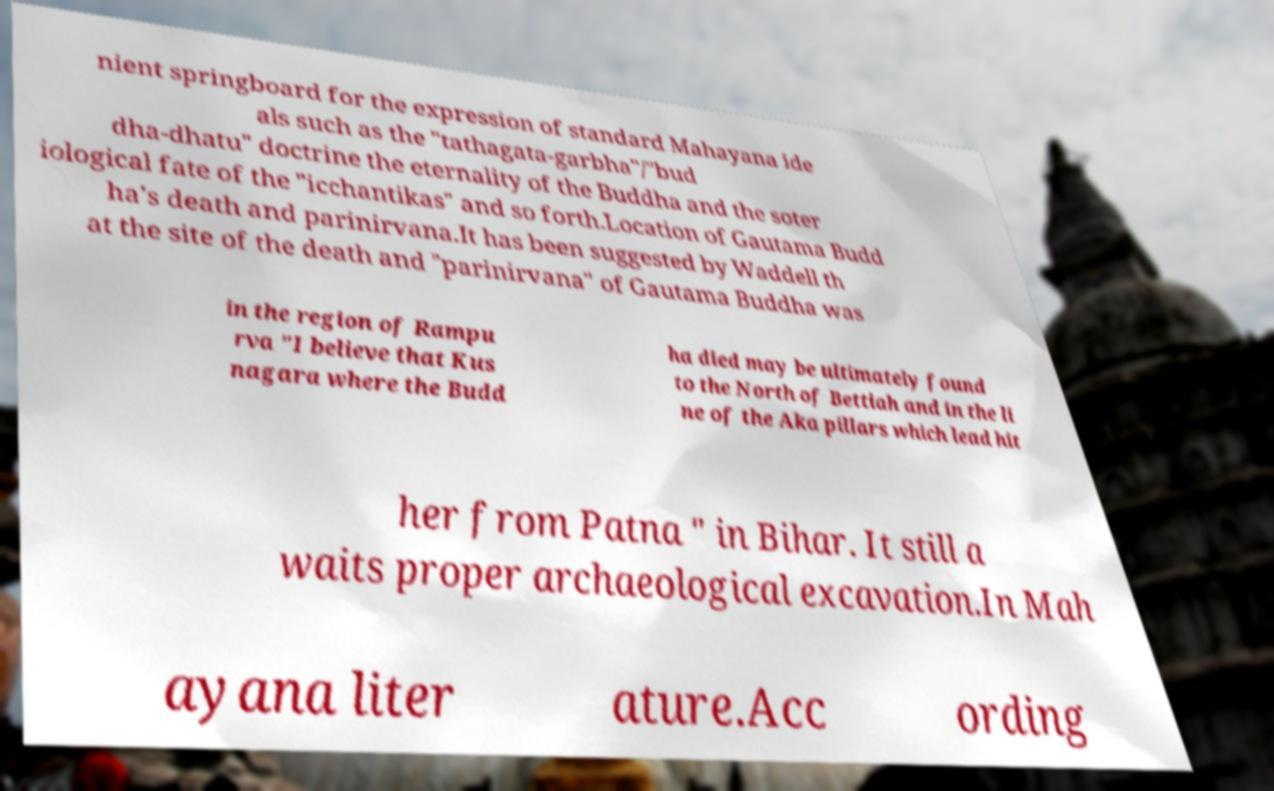What messages or text are displayed in this image? I need them in a readable, typed format. nient springboard for the expression of standard Mahayana ide als such as the "tathagata-garbha"/"bud dha-dhatu" doctrine the eternality of the Buddha and the soter iological fate of the "icchantikas" and so forth.Location of Gautama Budd ha's death and parinirvana.It has been suggested by Waddell th at the site of the death and "parinirvana" of Gautama Buddha was in the region of Rampu rva "I believe that Kus nagara where the Budd ha died may be ultimately found to the North of Bettiah and in the li ne of the Aka pillars which lead hit her from Patna " in Bihar. It still a waits proper archaeological excavation.In Mah ayana liter ature.Acc ording 